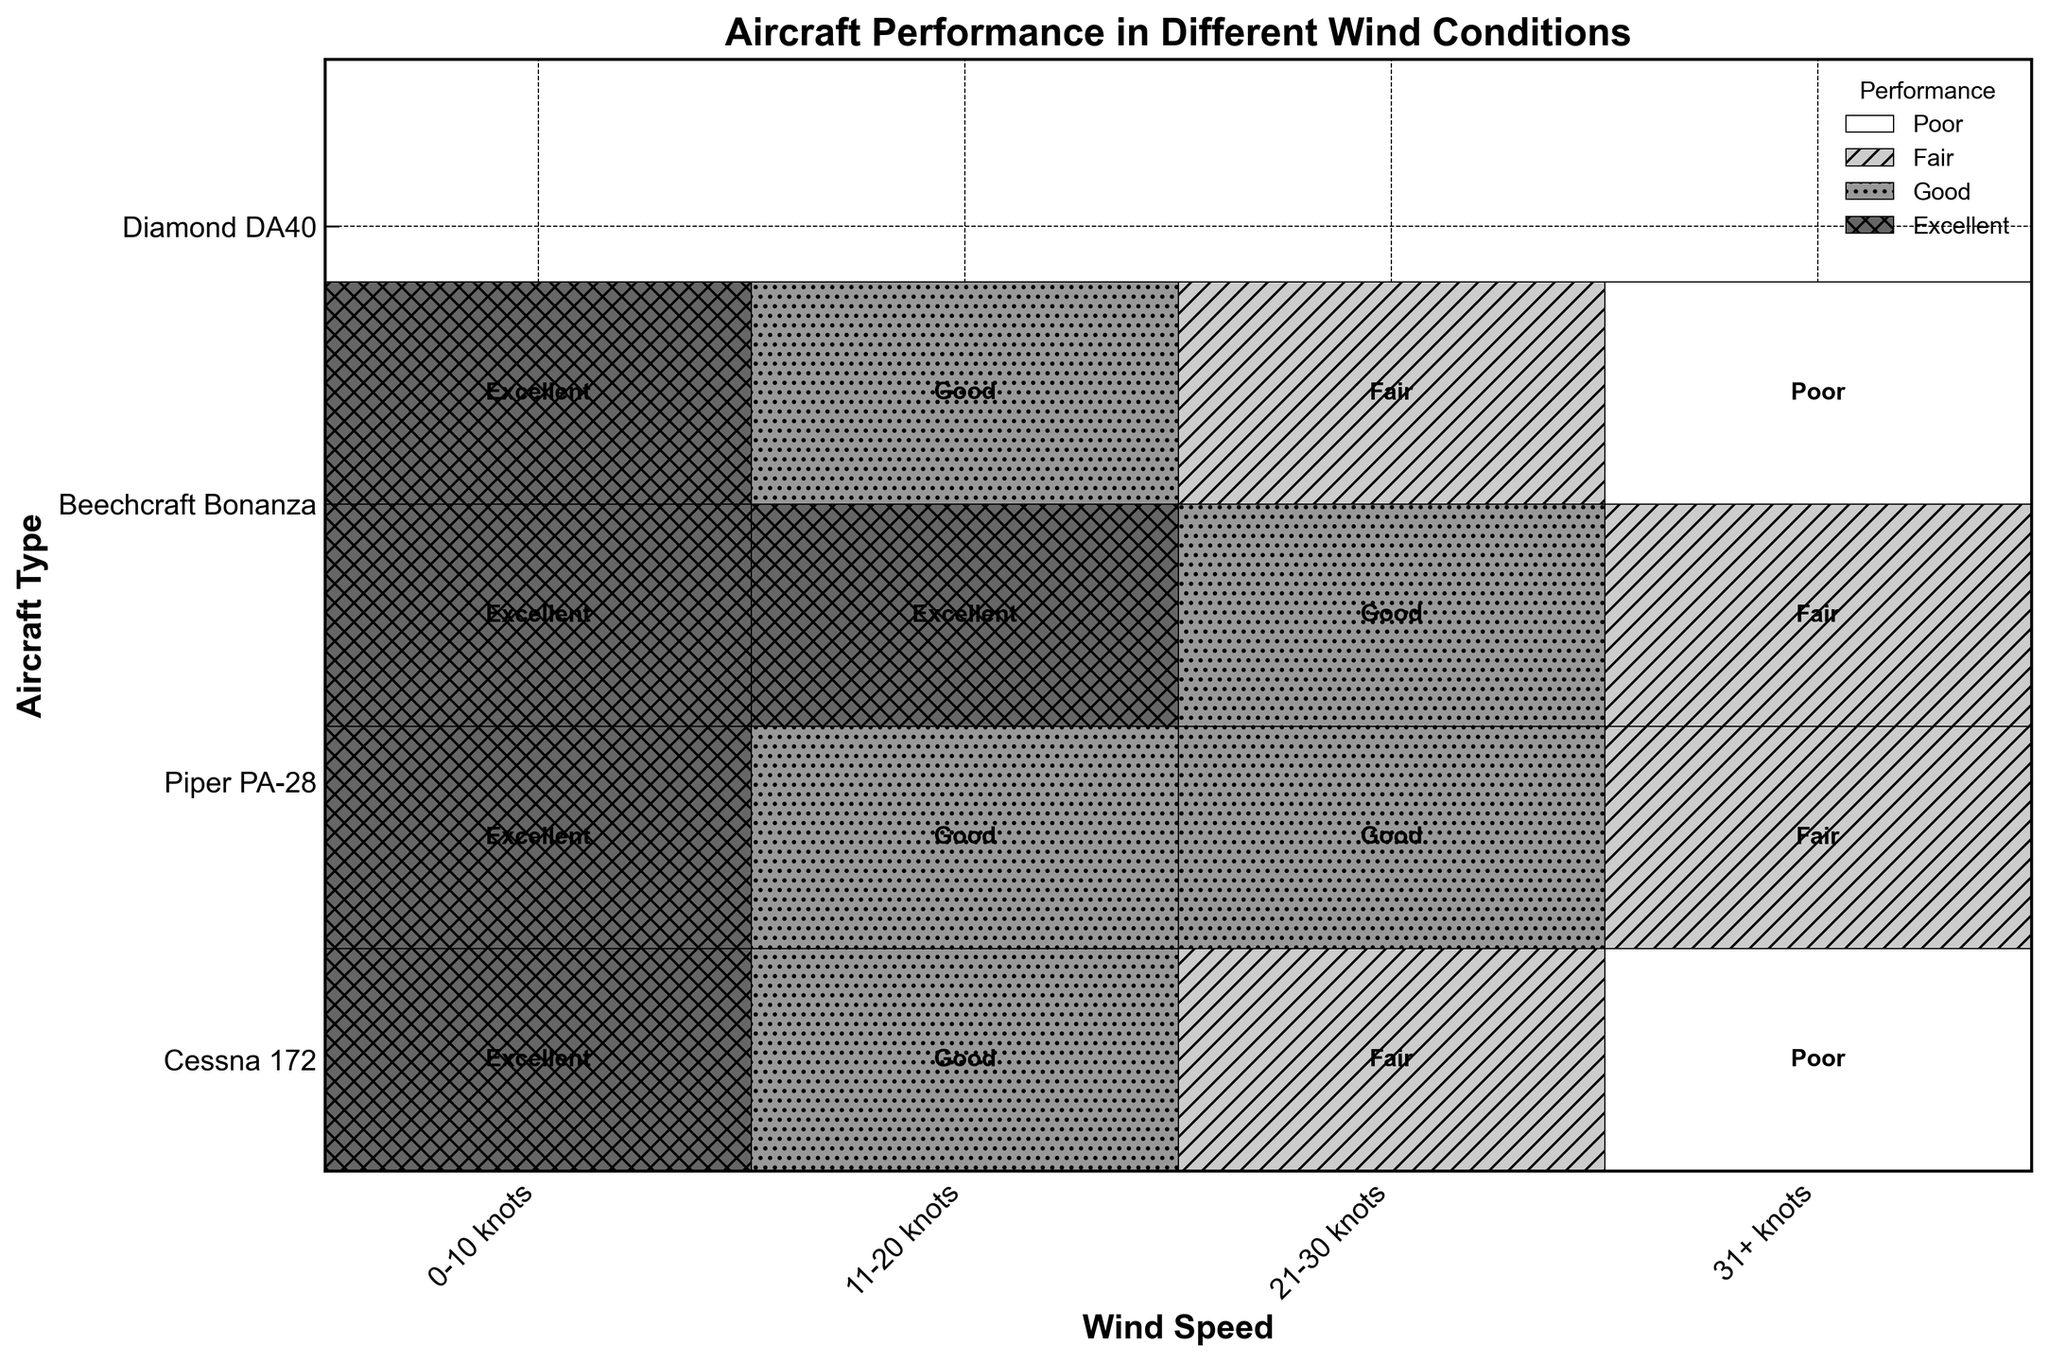Which wind speed range yields the best performance for most aircraft types? Most aircraft types have excellent performance in the 0-10 knots wind speed range. Observing the Excellent labels in that range across different aircraft confirms this.
Answer: 0-10 knots How does the performance of the Cessna 172 change across increasing wind speeds? The Cessna 172 has Excellent performance at 0-10 knots, Good at 11-20 knots, Fair at 21-30 knots, and Poor at 31+ knots. This trend shows a decline in performance with increasing wind speeds.
Answer: Declines from Excellent to Poor Which aircraft type is the most resilient in higher wind speeds (21-30 knots and above)? The Beechcraft Bonanza has Good performance at 21-30 knots and Fair at 31+ knots, whereas others have worse performance in these ranges.
Answer: Beechcraft Bonanza At which wind speed does the Piper PA-28 perform worse than Good? The Piper PA-28 performs Fair at 31+ knots. All other wind speeds have either Good or Excellent performance.
Answer: 31+ knots Compare the performance of the Diamond DA40 and Cessna 172 in the 21-30 knots wind speed range. The Diamond DA40 has Fair performance at 21-30 knots, whereas the Cessna 172 also has Fair performance in the same range.
Answer: Both Fair What is the overall performance trend for the Beechcraft Bonanza as wind speed increases? The Beechcraft Bonanza has Excellent performance at both 0-10 and 11-20 knots, Good at 21-30 knots, and Fair at 31+ knots, indicating decreasing performance with increasing wind speed.
Answer: Decreases from Excellent to Fair How many aircraft types have Excellent performance at 11-20 knots? Observing the Excellent labels, only the Beechcraft Bonanza has Excellent performance at 11-20 knots.
Answer: One (Beechcraft Bonanza) Identify the wind speed range at which the Diamond DA40 performs 'Poor'. The Diamond DA40 has Poor performance at 31+ knots, as indicated in the plot.
Answer: 31+ knots Which aircraft has the most consistent performance across different wind speeds? The Beechcraft Bonanza is the most consistent, maintaining Excellent to Good performance in lower winds and only dropping to Fair at the highest range (31+ knots).
Answer: Beechcraft Bonanza Count the number of aircraft that perform at least 'Good' in the 0-10 knots range. All four aircraft types (Cessna 172, Piper PA-28, Beechcraft Bonanza, and Diamond DA40) have Excellent performance in the 0-10 knots range.
Answer: Four 